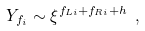Convert formula to latex. <formula><loc_0><loc_0><loc_500><loc_500>Y _ { f _ { i } } \sim \xi ^ { f _ { L i } + f _ { R i } + h } \ ,</formula> 